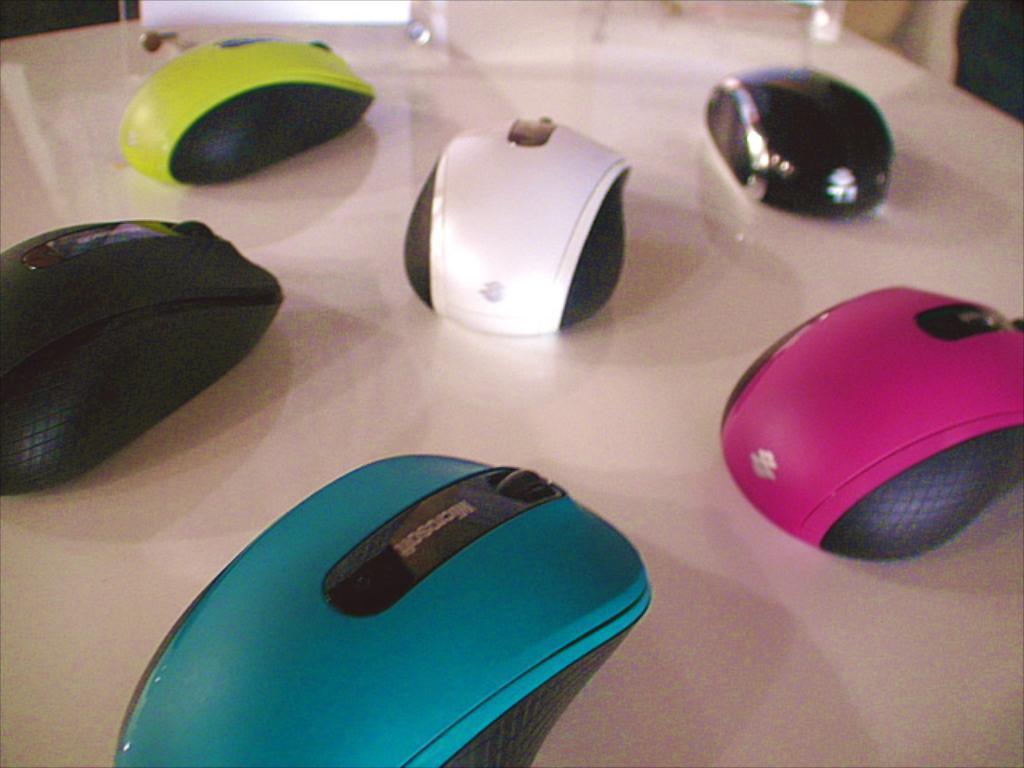In one or two sentences, can you explain what this image depicts? On this white surface we can see different colors of mouse´s.  